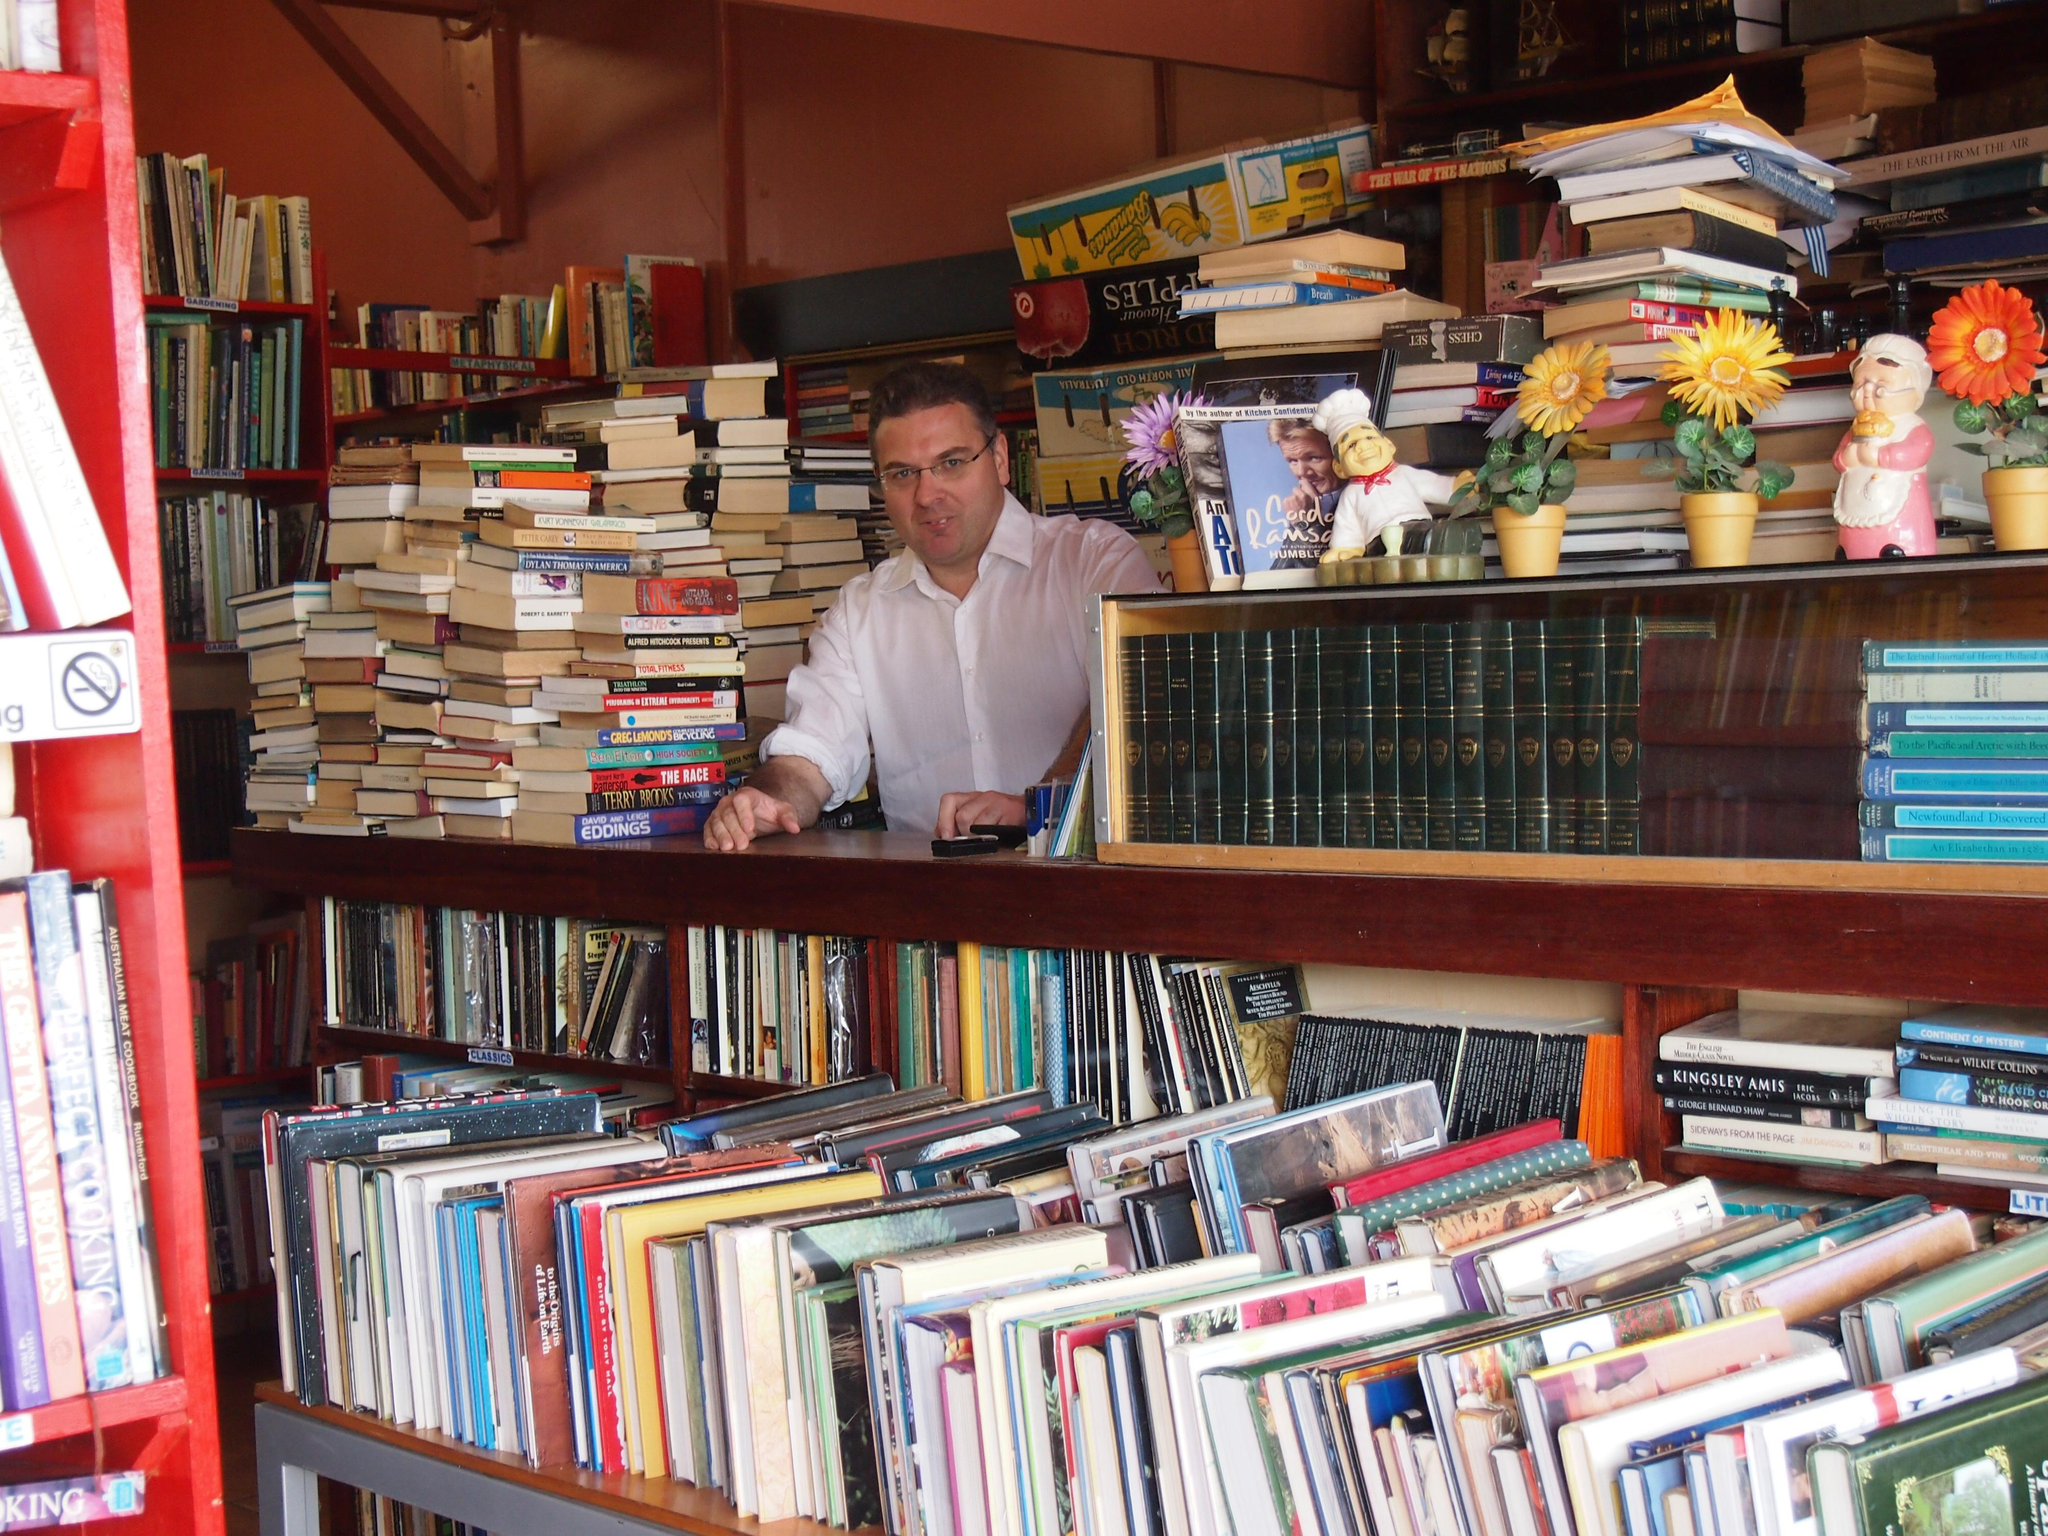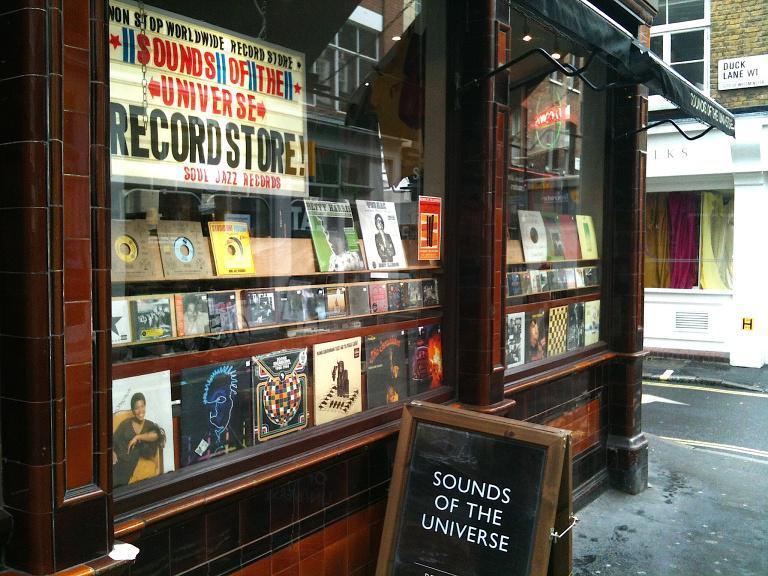The first image is the image on the left, the second image is the image on the right. Given the left and right images, does the statement "The people in the shop are standing up and browsing." hold true? Answer yes or no. No. The first image is the image on the left, the second image is the image on the right. Evaluate the accuracy of this statement regarding the images: "The left image shows the exterior of a shop with dark green signage and at least one table of items in front of one of the square glass windows flanking a single door.". Is it true? Answer yes or no. No. 